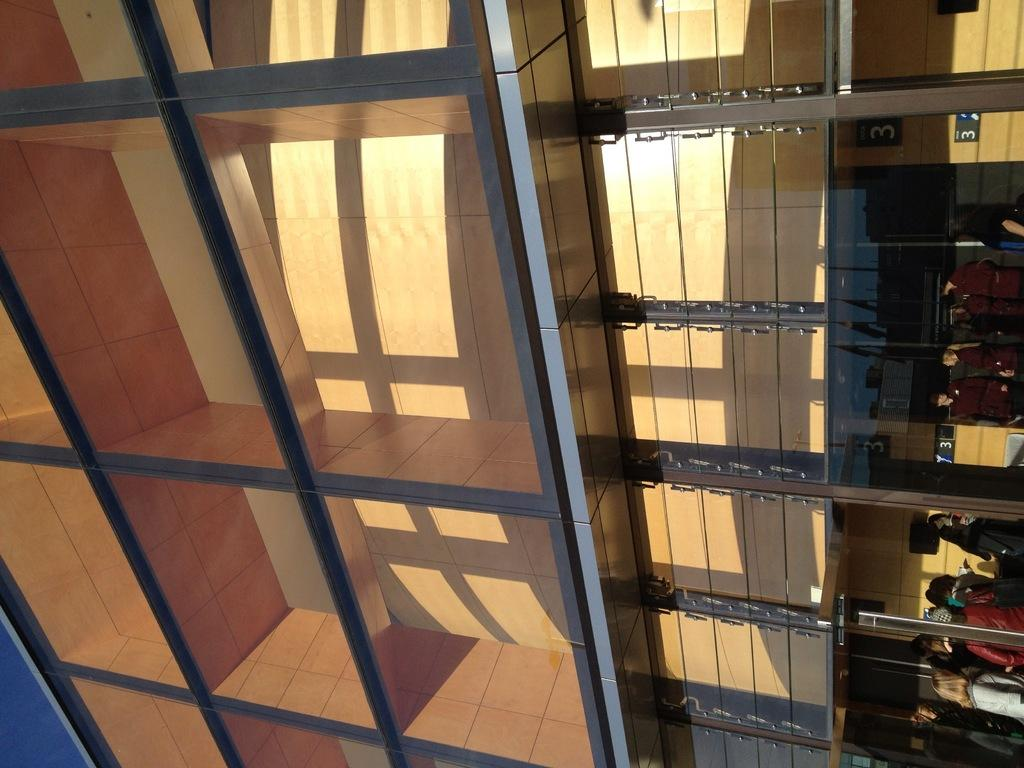Provide a one-sentence caption for the provided image. some numbers are fixed on the back board such as number 3. 